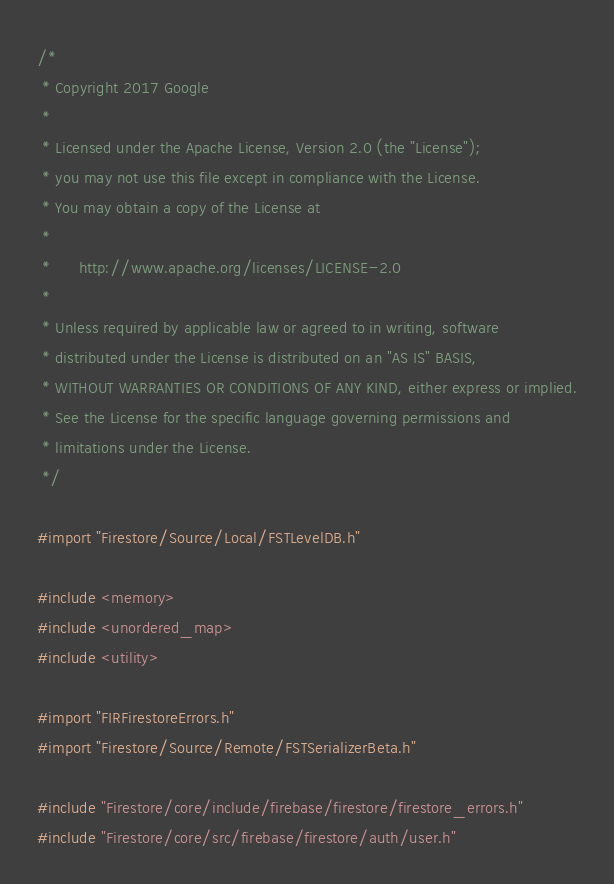<code> <loc_0><loc_0><loc_500><loc_500><_ObjectiveC_>/*
 * Copyright 2017 Google
 *
 * Licensed under the Apache License, Version 2.0 (the "License");
 * you may not use this file except in compliance with the License.
 * You may obtain a copy of the License at
 *
 *      http://www.apache.org/licenses/LICENSE-2.0
 *
 * Unless required by applicable law or agreed to in writing, software
 * distributed under the License is distributed on an "AS IS" BASIS,
 * WITHOUT WARRANTIES OR CONDITIONS OF ANY KIND, either express or implied.
 * See the License for the specific language governing permissions and
 * limitations under the License.
 */

#import "Firestore/Source/Local/FSTLevelDB.h"

#include <memory>
#include <unordered_map>
#include <utility>

#import "FIRFirestoreErrors.h"
#import "Firestore/Source/Remote/FSTSerializerBeta.h"

#include "Firestore/core/include/firebase/firestore/firestore_errors.h"
#include "Firestore/core/src/firebase/firestore/auth/user.h"</code> 